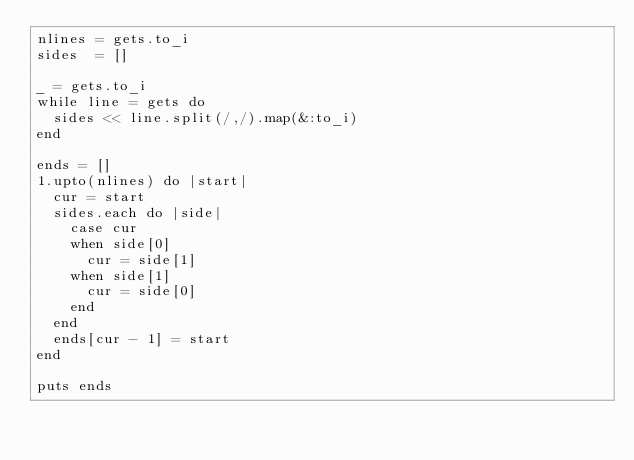<code> <loc_0><loc_0><loc_500><loc_500><_Ruby_>nlines = gets.to_i
sides  = []

_ = gets.to_i
while line = gets do
  sides << line.split(/,/).map(&:to_i)
end

ends = []
1.upto(nlines) do |start|
  cur = start
  sides.each do |side|
    case cur
    when side[0]
      cur = side[1]
    when side[1]
      cur = side[0]
    end
  end
  ends[cur - 1] = start
end

puts ends</code> 